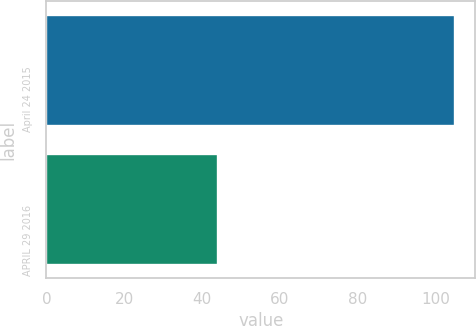<chart> <loc_0><loc_0><loc_500><loc_500><bar_chart><fcel>April 24 2015<fcel>APRIL 29 2016<nl><fcel>105<fcel>44<nl></chart> 